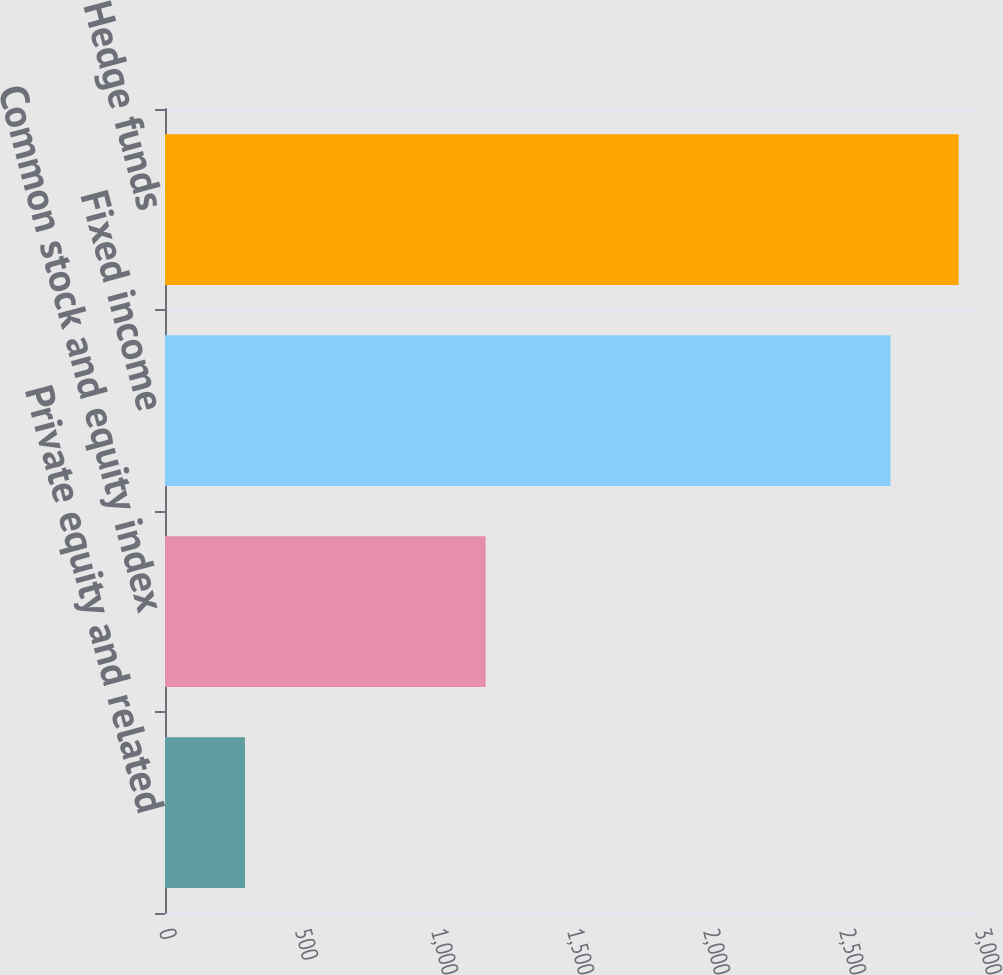Convert chart to OTSL. <chart><loc_0><loc_0><loc_500><loc_500><bar_chart><fcel>Private equity and related<fcel>Common stock and equity index<fcel>Fixed income<fcel>Hedge funds<nl><fcel>294<fcel>1179<fcel>2667<fcel>2917.8<nl></chart> 